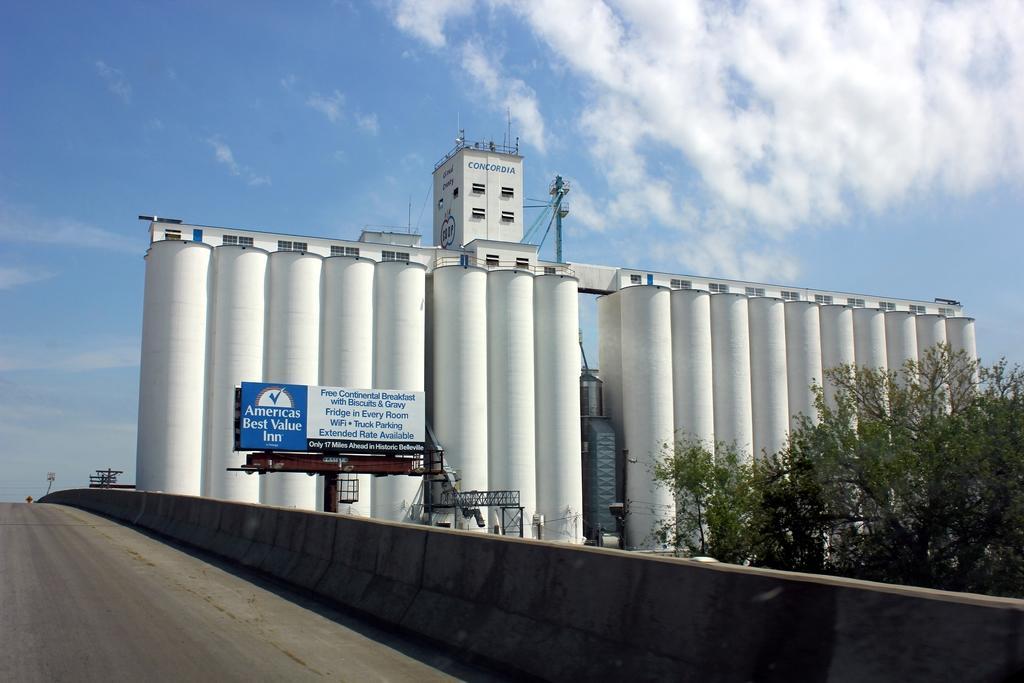Can you describe this image briefly? Right side of the image we can see tree ,road and wall. We can see board and above the pillars we can see building with windows and we can see pole. In the background we can see sky with clouds. 